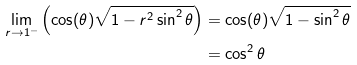Convert formula to latex. <formula><loc_0><loc_0><loc_500><loc_500>\lim _ { r \rightarrow 1 ^ { - } } \left ( \cos ( \theta ) \sqrt { 1 - r ^ { 2 } \sin ^ { 2 } \theta } \right ) & = \cos ( \theta ) \sqrt { 1 - \sin ^ { 2 } \theta } \\ & = \cos ^ { 2 } \theta</formula> 